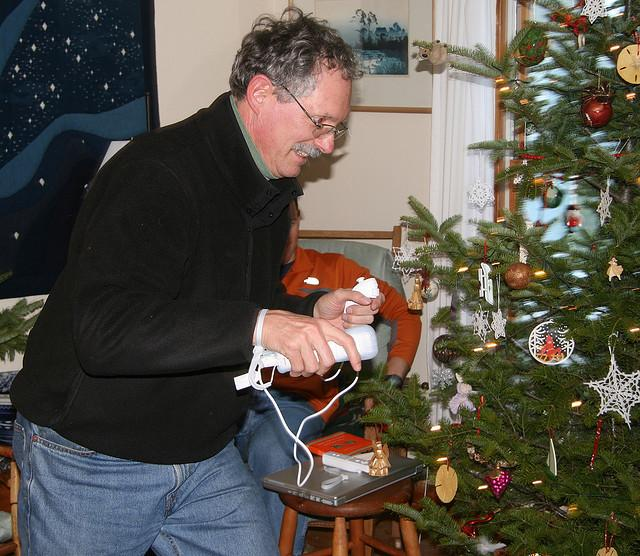What is the month depicted in the image?

Choices:
A) november
B) december
C) january
D) february december 